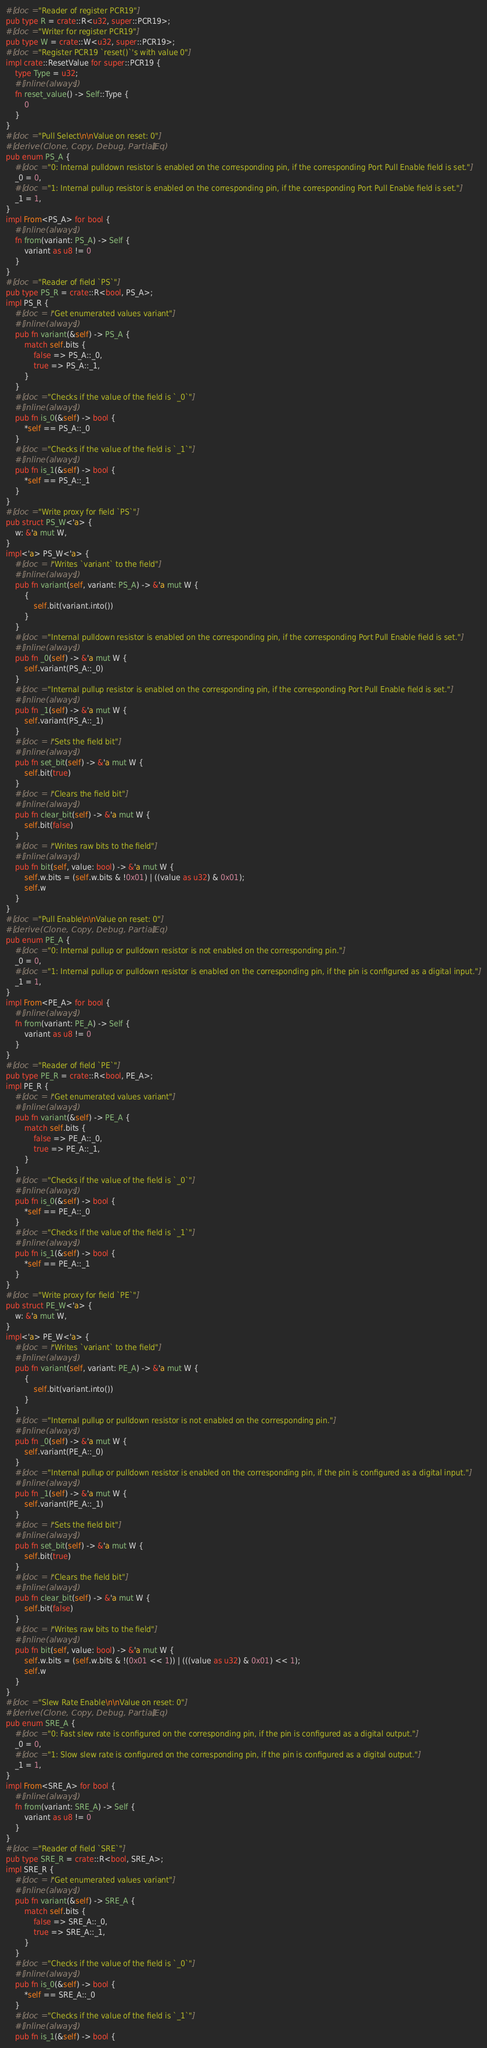<code> <loc_0><loc_0><loc_500><loc_500><_Rust_>#[doc = "Reader of register PCR19"]
pub type R = crate::R<u32, super::PCR19>;
#[doc = "Writer for register PCR19"]
pub type W = crate::W<u32, super::PCR19>;
#[doc = "Register PCR19 `reset()`'s with value 0"]
impl crate::ResetValue for super::PCR19 {
    type Type = u32;
    #[inline(always)]
    fn reset_value() -> Self::Type {
        0
    }
}
#[doc = "Pull Select\n\nValue on reset: 0"]
#[derive(Clone, Copy, Debug, PartialEq)]
pub enum PS_A {
    #[doc = "0: Internal pulldown resistor is enabled on the corresponding pin, if the corresponding Port Pull Enable field is set."]
    _0 = 0,
    #[doc = "1: Internal pullup resistor is enabled on the corresponding pin, if the corresponding Port Pull Enable field is set."]
    _1 = 1,
}
impl From<PS_A> for bool {
    #[inline(always)]
    fn from(variant: PS_A) -> Self {
        variant as u8 != 0
    }
}
#[doc = "Reader of field `PS`"]
pub type PS_R = crate::R<bool, PS_A>;
impl PS_R {
    #[doc = r"Get enumerated values variant"]
    #[inline(always)]
    pub fn variant(&self) -> PS_A {
        match self.bits {
            false => PS_A::_0,
            true => PS_A::_1,
        }
    }
    #[doc = "Checks if the value of the field is `_0`"]
    #[inline(always)]
    pub fn is_0(&self) -> bool {
        *self == PS_A::_0
    }
    #[doc = "Checks if the value of the field is `_1`"]
    #[inline(always)]
    pub fn is_1(&self) -> bool {
        *self == PS_A::_1
    }
}
#[doc = "Write proxy for field `PS`"]
pub struct PS_W<'a> {
    w: &'a mut W,
}
impl<'a> PS_W<'a> {
    #[doc = r"Writes `variant` to the field"]
    #[inline(always)]
    pub fn variant(self, variant: PS_A) -> &'a mut W {
        {
            self.bit(variant.into())
        }
    }
    #[doc = "Internal pulldown resistor is enabled on the corresponding pin, if the corresponding Port Pull Enable field is set."]
    #[inline(always)]
    pub fn _0(self) -> &'a mut W {
        self.variant(PS_A::_0)
    }
    #[doc = "Internal pullup resistor is enabled on the corresponding pin, if the corresponding Port Pull Enable field is set."]
    #[inline(always)]
    pub fn _1(self) -> &'a mut W {
        self.variant(PS_A::_1)
    }
    #[doc = r"Sets the field bit"]
    #[inline(always)]
    pub fn set_bit(self) -> &'a mut W {
        self.bit(true)
    }
    #[doc = r"Clears the field bit"]
    #[inline(always)]
    pub fn clear_bit(self) -> &'a mut W {
        self.bit(false)
    }
    #[doc = r"Writes raw bits to the field"]
    #[inline(always)]
    pub fn bit(self, value: bool) -> &'a mut W {
        self.w.bits = (self.w.bits & !0x01) | ((value as u32) & 0x01);
        self.w
    }
}
#[doc = "Pull Enable\n\nValue on reset: 0"]
#[derive(Clone, Copy, Debug, PartialEq)]
pub enum PE_A {
    #[doc = "0: Internal pullup or pulldown resistor is not enabled on the corresponding pin."]
    _0 = 0,
    #[doc = "1: Internal pullup or pulldown resistor is enabled on the corresponding pin, if the pin is configured as a digital input."]
    _1 = 1,
}
impl From<PE_A> for bool {
    #[inline(always)]
    fn from(variant: PE_A) -> Self {
        variant as u8 != 0
    }
}
#[doc = "Reader of field `PE`"]
pub type PE_R = crate::R<bool, PE_A>;
impl PE_R {
    #[doc = r"Get enumerated values variant"]
    #[inline(always)]
    pub fn variant(&self) -> PE_A {
        match self.bits {
            false => PE_A::_0,
            true => PE_A::_1,
        }
    }
    #[doc = "Checks if the value of the field is `_0`"]
    #[inline(always)]
    pub fn is_0(&self) -> bool {
        *self == PE_A::_0
    }
    #[doc = "Checks if the value of the field is `_1`"]
    #[inline(always)]
    pub fn is_1(&self) -> bool {
        *self == PE_A::_1
    }
}
#[doc = "Write proxy for field `PE`"]
pub struct PE_W<'a> {
    w: &'a mut W,
}
impl<'a> PE_W<'a> {
    #[doc = r"Writes `variant` to the field"]
    #[inline(always)]
    pub fn variant(self, variant: PE_A) -> &'a mut W {
        {
            self.bit(variant.into())
        }
    }
    #[doc = "Internal pullup or pulldown resistor is not enabled on the corresponding pin."]
    #[inline(always)]
    pub fn _0(self) -> &'a mut W {
        self.variant(PE_A::_0)
    }
    #[doc = "Internal pullup or pulldown resistor is enabled on the corresponding pin, if the pin is configured as a digital input."]
    #[inline(always)]
    pub fn _1(self) -> &'a mut W {
        self.variant(PE_A::_1)
    }
    #[doc = r"Sets the field bit"]
    #[inline(always)]
    pub fn set_bit(self) -> &'a mut W {
        self.bit(true)
    }
    #[doc = r"Clears the field bit"]
    #[inline(always)]
    pub fn clear_bit(self) -> &'a mut W {
        self.bit(false)
    }
    #[doc = r"Writes raw bits to the field"]
    #[inline(always)]
    pub fn bit(self, value: bool) -> &'a mut W {
        self.w.bits = (self.w.bits & !(0x01 << 1)) | (((value as u32) & 0x01) << 1);
        self.w
    }
}
#[doc = "Slew Rate Enable\n\nValue on reset: 0"]
#[derive(Clone, Copy, Debug, PartialEq)]
pub enum SRE_A {
    #[doc = "0: Fast slew rate is configured on the corresponding pin, if the pin is configured as a digital output."]
    _0 = 0,
    #[doc = "1: Slow slew rate is configured on the corresponding pin, if the pin is configured as a digital output."]
    _1 = 1,
}
impl From<SRE_A> for bool {
    #[inline(always)]
    fn from(variant: SRE_A) -> Self {
        variant as u8 != 0
    }
}
#[doc = "Reader of field `SRE`"]
pub type SRE_R = crate::R<bool, SRE_A>;
impl SRE_R {
    #[doc = r"Get enumerated values variant"]
    #[inline(always)]
    pub fn variant(&self) -> SRE_A {
        match self.bits {
            false => SRE_A::_0,
            true => SRE_A::_1,
        }
    }
    #[doc = "Checks if the value of the field is `_0`"]
    #[inline(always)]
    pub fn is_0(&self) -> bool {
        *self == SRE_A::_0
    }
    #[doc = "Checks if the value of the field is `_1`"]
    #[inline(always)]
    pub fn is_1(&self) -> bool {</code> 